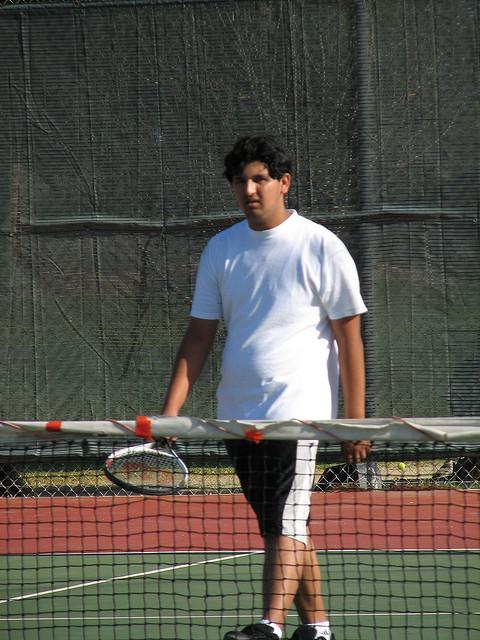What color is the man's shirt?
Write a very short answer. White. What sport is shown?
Concise answer only. Tennis. Are there clouds?
Short answer required. No. Is the tennis player right-handed?
Write a very short answer. Yes. 